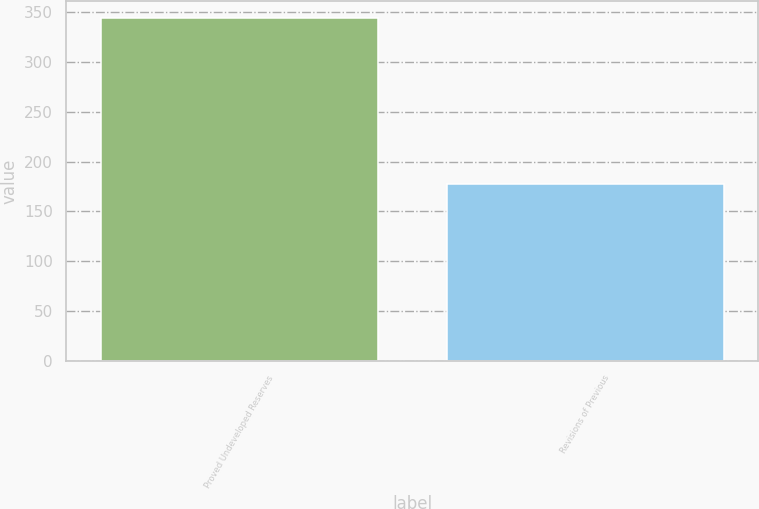Convert chart to OTSL. <chart><loc_0><loc_0><loc_500><loc_500><bar_chart><fcel>Proved Undeveloped Reserves<fcel>Revisions of Previous<nl><fcel>344<fcel>177<nl></chart> 